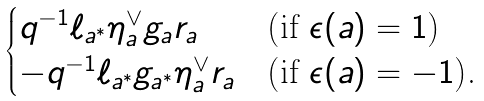<formula> <loc_0><loc_0><loc_500><loc_500>\begin{cases} q ^ { - 1 } \ell _ { a ^ { * } } \eta _ { a } ^ { \vee } g _ { a } r _ { a } & \text {(if $\epsilon(a)=1$)} \\ - q ^ { - 1 } \ell _ { a ^ { * } } g _ { a ^ { * } } \eta _ { a } ^ { \vee } r _ { a } & \text {(if $\epsilon(a)=-1$).} \end{cases}</formula> 